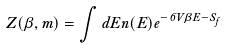Convert formula to latex. <formula><loc_0><loc_0><loc_500><loc_500>Z ( \beta , m ) = \int d E n ( E ) e ^ { - 6 V \beta E - S _ { f } }</formula> 